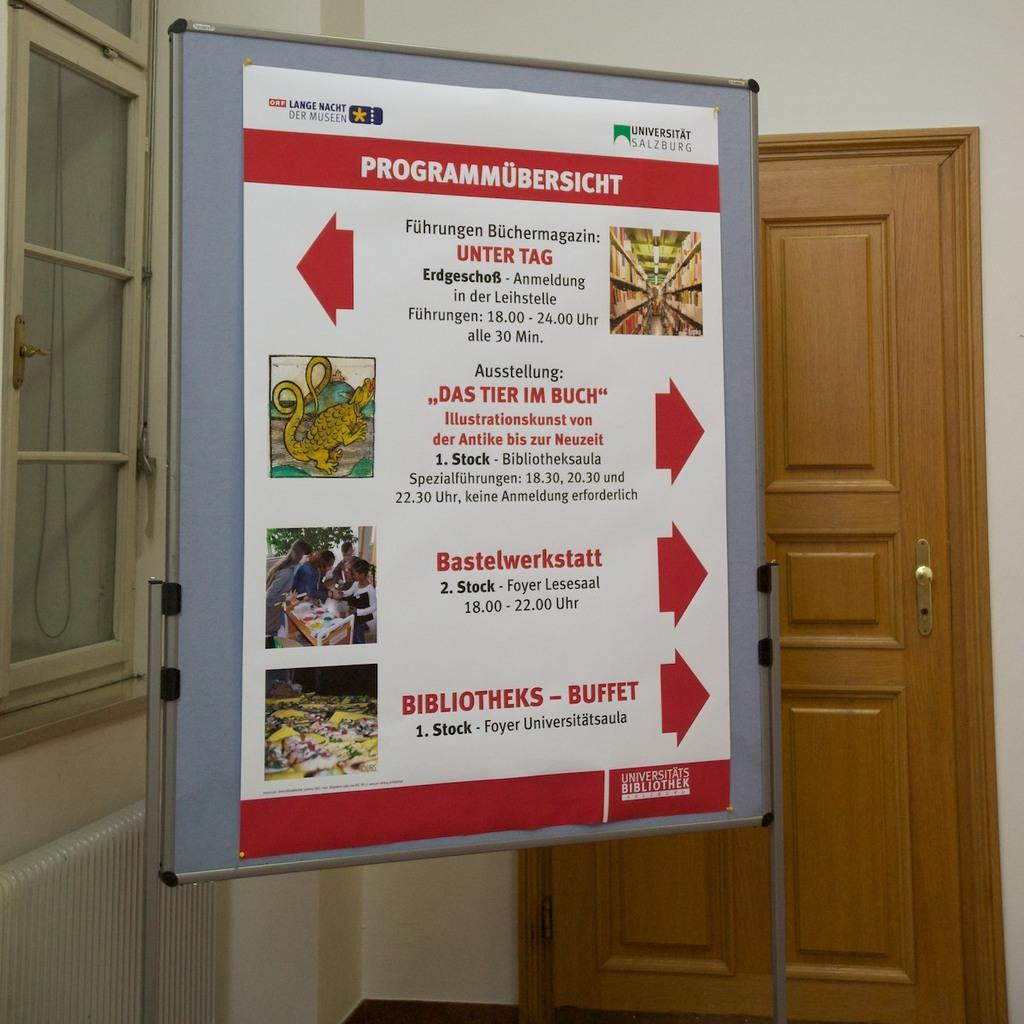<image>
Write a terse but informative summary of the picture. A poster which is mostly in red and white and has the words Lange Nacht written on the top right 